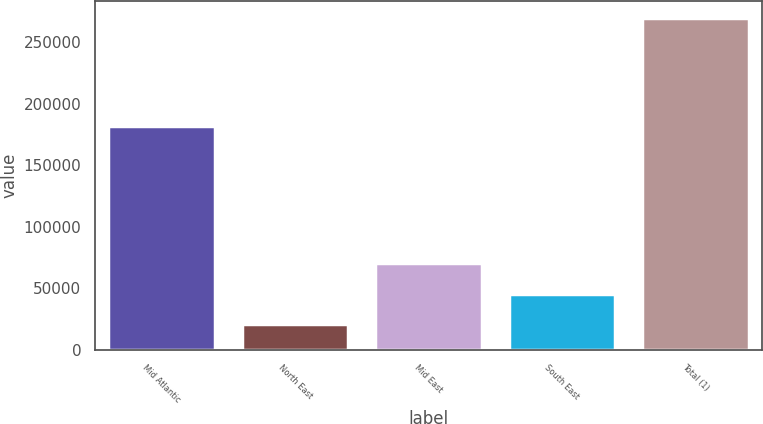Convert chart. <chart><loc_0><loc_0><loc_500><loc_500><bar_chart><fcel>Mid Atlantic<fcel>North East<fcel>Mid East<fcel>South East<fcel>Total (1)<nl><fcel>182128<fcel>20703<fcel>70572<fcel>45637.5<fcel>270048<nl></chart> 